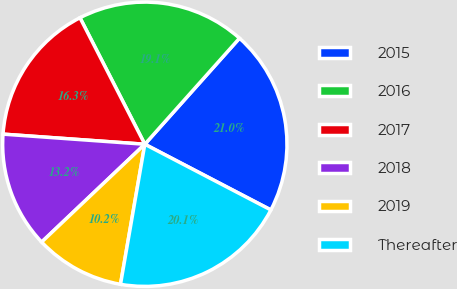<chart> <loc_0><loc_0><loc_500><loc_500><pie_chart><fcel>2015<fcel>2016<fcel>2017<fcel>2018<fcel>2019<fcel>Thereafter<nl><fcel>21.05%<fcel>19.14%<fcel>16.33%<fcel>13.21%<fcel>10.19%<fcel>20.09%<nl></chart> 